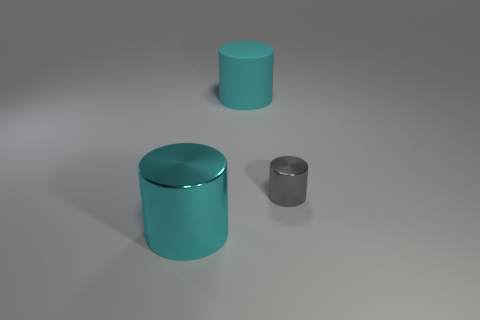How big is the cylinder that is in front of the big cyan matte thing and behind the cyan shiny object?
Keep it short and to the point. Small. How many green things have the same material as the gray cylinder?
Keep it short and to the point. 0. What is the shape of the other object that is the same color as the big matte thing?
Make the answer very short. Cylinder. The large metal cylinder is what color?
Make the answer very short. Cyan. Do the cyan object behind the small cylinder and the gray metallic object have the same shape?
Offer a very short reply. Yes. How many objects are large cyan things that are behind the big cyan metallic cylinder or cyan rubber cylinders?
Your response must be concise. 1. Is there another large thing that has the same shape as the gray metallic object?
Give a very brief answer. Yes. What shape is the other cyan thing that is the same size as the cyan metallic thing?
Keep it short and to the point. Cylinder. What is the shape of the object that is in front of the metallic cylinder that is to the right of the large cyan object to the left of the large rubber cylinder?
Make the answer very short. Cylinder. There is a rubber thing; is its shape the same as the shiny thing behind the cyan metal cylinder?
Give a very brief answer. Yes. 